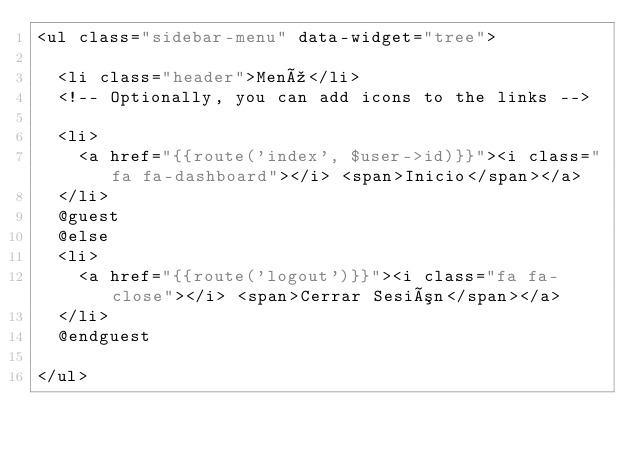<code> <loc_0><loc_0><loc_500><loc_500><_PHP_><ul class="sidebar-menu" data-widget="tree">

  <li class="header">Menú</li>
  <!-- Optionally, you can add icons to the links -->

  <li>
    <a href="{{route('index', $user->id)}}"><i class="fa fa-dashboard"></i> <span>Inicio</span></a>
  </li>
  @guest
  @else
  <li>
    <a href="{{route('logout')}}"><i class="fa fa-close"></i> <span>Cerrar Sesión</span></a>
  </li>
  @endguest

</ul></code> 